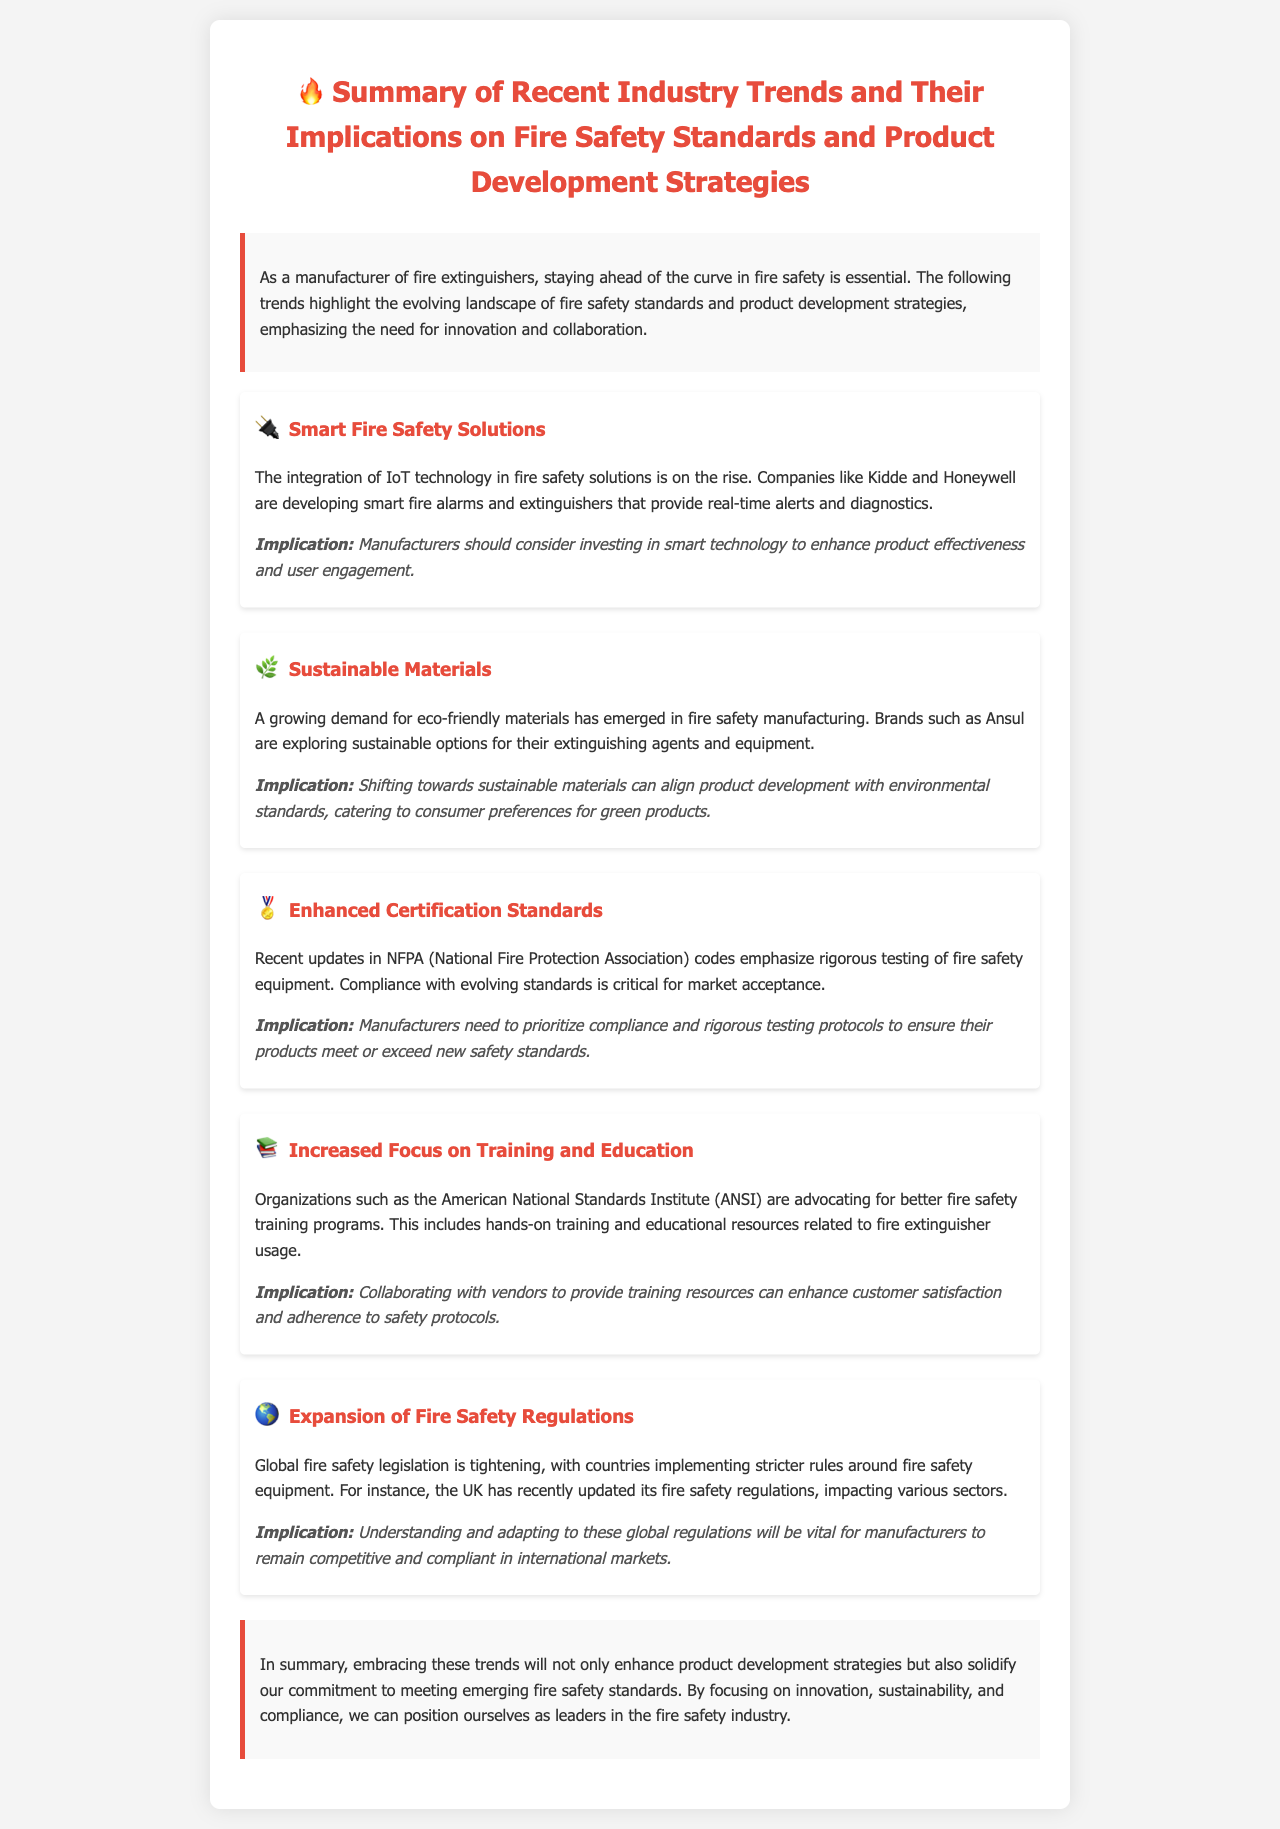What is the main focus of the document? The document outlines the summary of recent industry trends and their implications for fire safety standards and product development strategies.
Answer: Fire safety standards and product development strategies Which company is mentioned as developing smart fire solutions? Kidde and Honeywell are specifically named as companies developing smart fire alarms and extinguishers.
Answer: Kidde and Honeywell What trend emphasizes the use of eco-friendly materials? The document states that there is a growing demand for sustainable materials in fire safety manufacturing, particularly noted by brands like Ansul.
Answer: Sustainable Materials What organization is advocating for better fire safety training programs? The American National Standards Institute (ANSI) is the organization mentioned in relation to advocating for improved fire safety training.
Answer: American National Standards Institute (ANSI) What implication arises from enhanced certification standards? Manufacturers need to prioritize compliance and rigorous testing protocols to ensure their products meet or exceed new safety standards.
Answer: Compliance and rigorous testing What does the document suggest about global fire safety legislation? It indicates that global fire safety legislation is tightening, with countries implementing stricter rules around fire safety equipment.
Answer: Stricter rules What is recommended for manufacturers concerning smart technology? The document suggests that manufacturers should consider investing in smart technology for enhancing product effectiveness and user engagement.
Answer: Investing in smart technology 